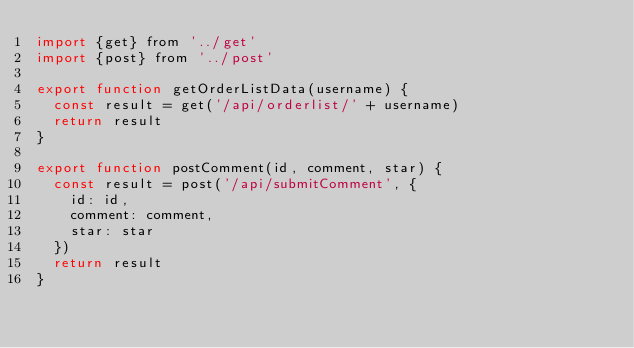<code> <loc_0><loc_0><loc_500><loc_500><_JavaScript_>import {get} from '../get'
import {post} from '../post'

export function getOrderListData(username) {
  const result = get('/api/orderlist/' + username)
  return result
}

export function postComment(id, comment, star) {
  const result = post('/api/submitComment', {
    id: id,
    comment: comment,
    star: star
  })
  return result
}</code> 